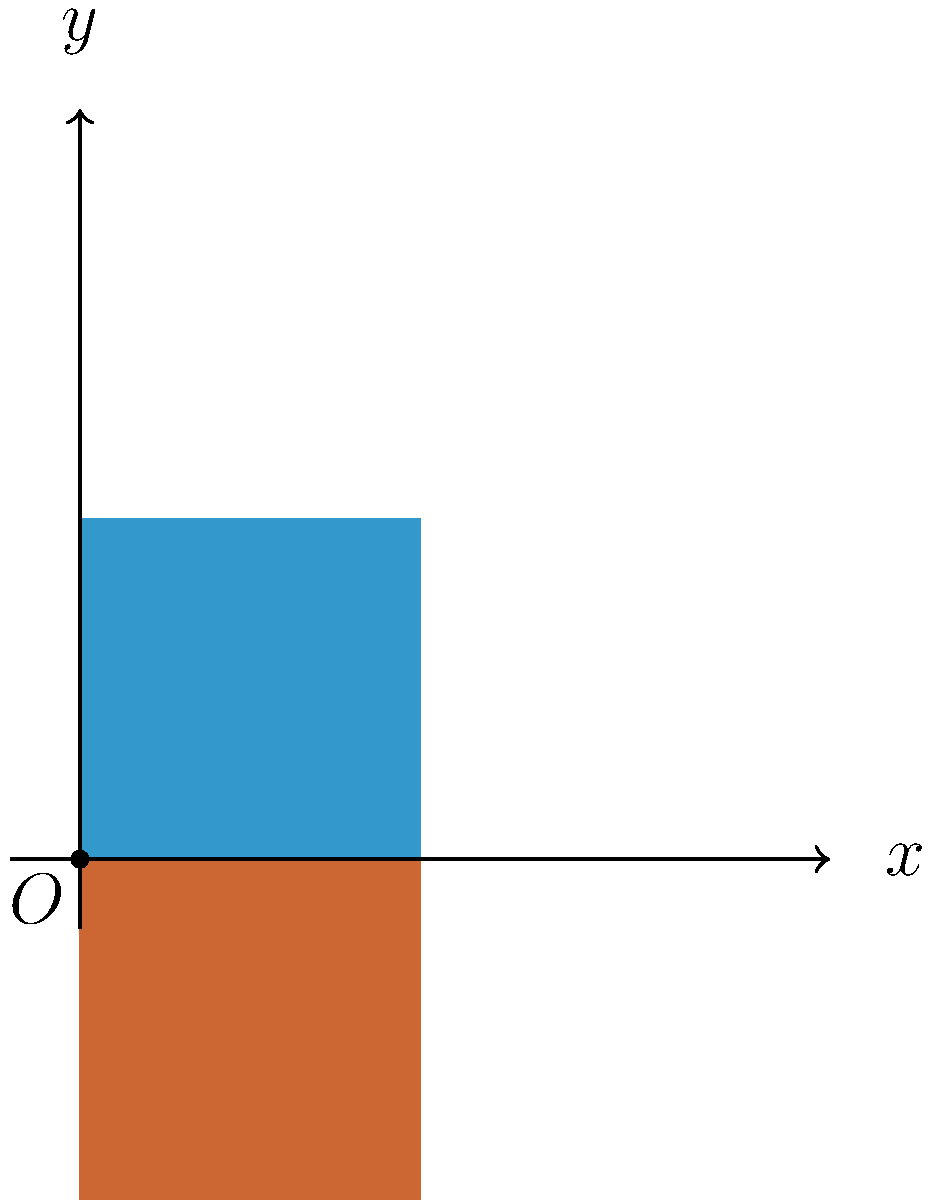In designing an intuitive user interface for a digital accessibility application, you need to create a symmetrical design using shape reflection. Given the blue rectangle in the first quadrant of the coordinate plane, which transformation would correctly produce the orange rectangle to create a symmetrical design across the x-axis? To create a symmetrical design across the x-axis, we need to reflect the blue rectangle over the x-axis. Here's how we can determine the correct transformation:

1. Observe that the blue rectangle is in the first quadrant (positive x and y values).
2. To reflect a shape across the x-axis, we need to change the sign of all y-coordinates while keeping the x-coordinates the same.
3. In mathematical notation, this transformation can be represented as $(x, y) \rightarrow (x, -y)$.
4. This transformation is known as a reflection over the x-axis.
5. The matrix representation for this reflection is:
   $$\begin{pmatrix} 1 & 0 \\ 0 & -1 \end{pmatrix}$$
6. Applying this transformation to every point of the blue rectangle will produce the orange rectangle in the fourth quadrant.
7. The resulting design is symmetrical across the x-axis, which is a common technique used in creating intuitive and balanced user interfaces.
Answer: Reflection over the x-axis: $(x, y) \rightarrow (x, -y)$ 